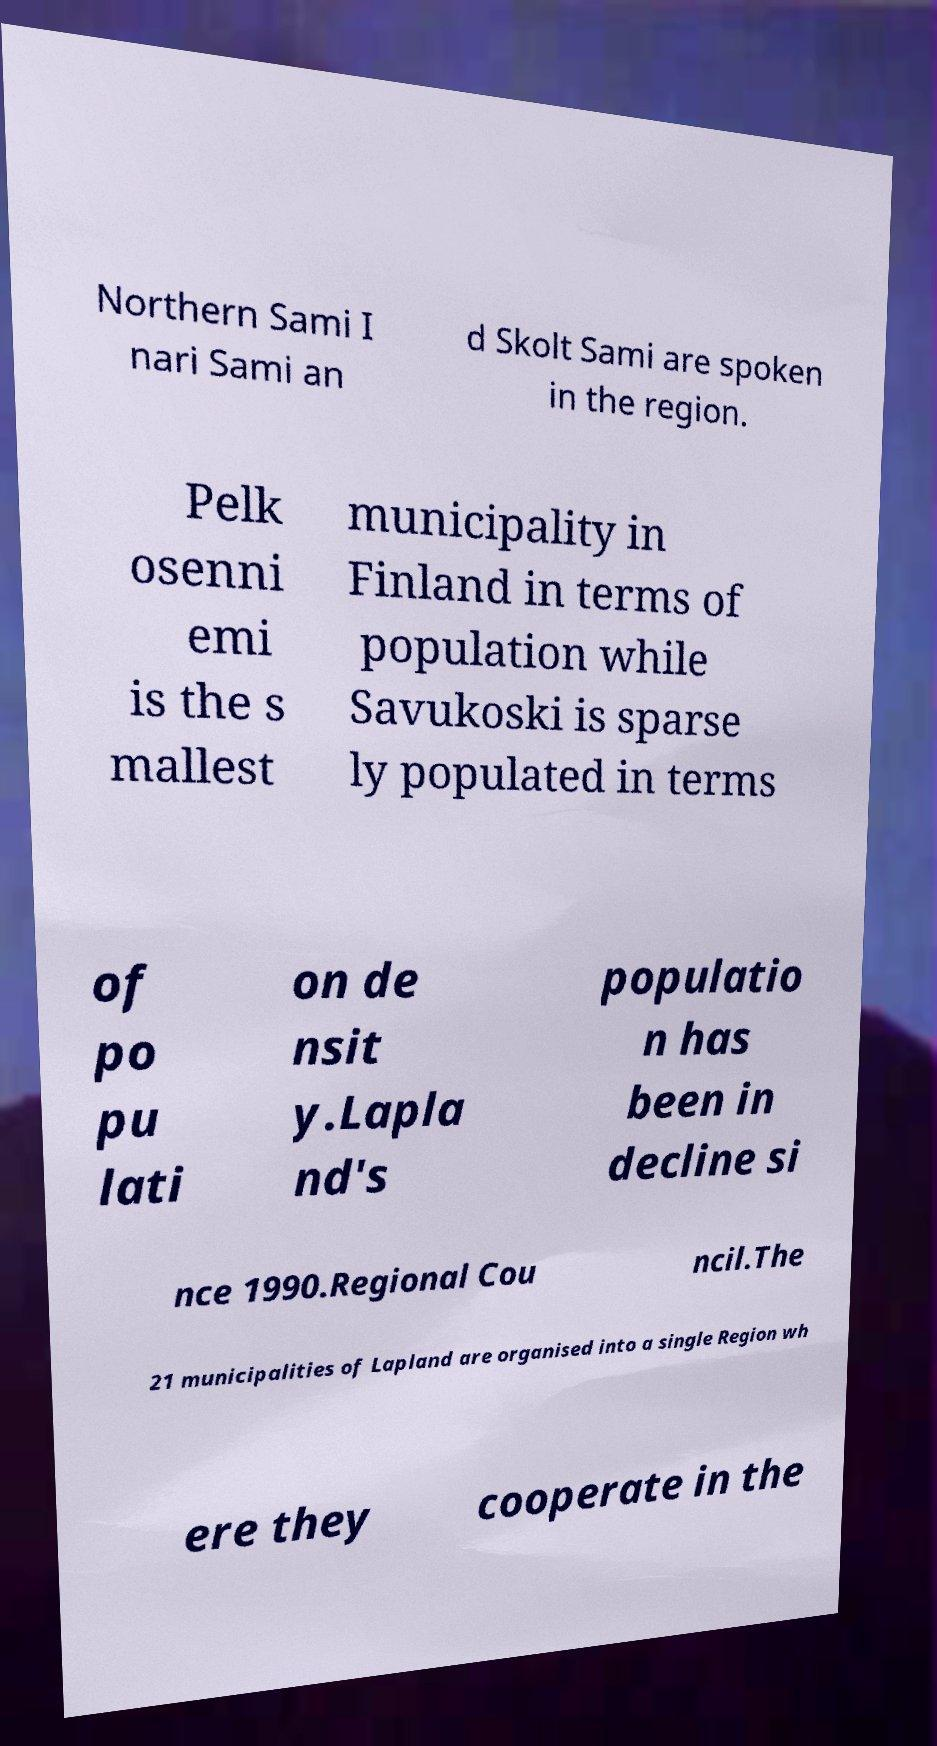Could you extract and type out the text from this image? Northern Sami I nari Sami an d Skolt Sami are spoken in the region. Pelk osenni emi is the s mallest municipality in Finland in terms of population while Savukoski is sparse ly populated in terms of po pu lati on de nsit y.Lapla nd's populatio n has been in decline si nce 1990.Regional Cou ncil.The 21 municipalities of Lapland are organised into a single Region wh ere they cooperate in the 